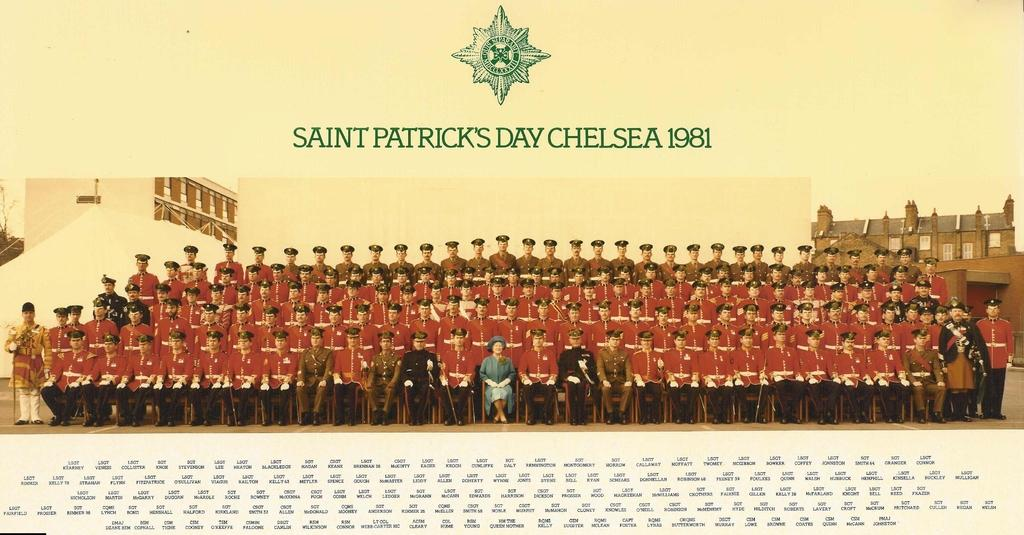Provide a one-sentence caption for the provided image. A photo of men wearing red military jackets from Saint Patrick's Day Chelsea 1981. 